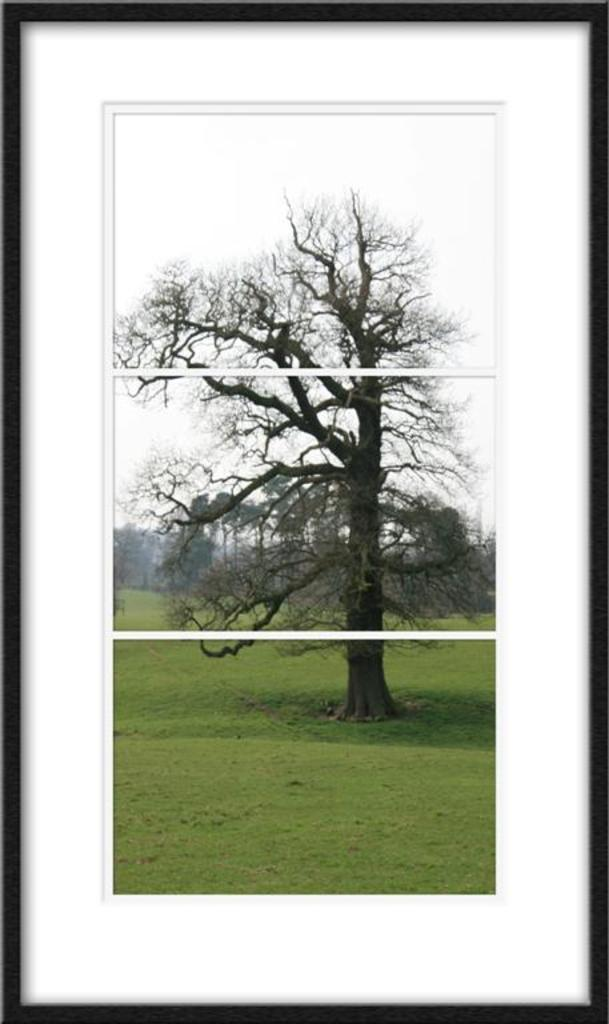What is the main subject in the center of the image? There is a photo frame in the center of the image. What is depicted within the photo frame? The photo frame contains an image of the sky, trees, and grass. How many knots are visible in the image? There are no knots present in the image; it features a photo frame with images of the sky, trees, and grass. What type of hill is shown in the image? There is no hill depicted in the image; it only contains images of the sky, trees, and grass within the photo frame. 